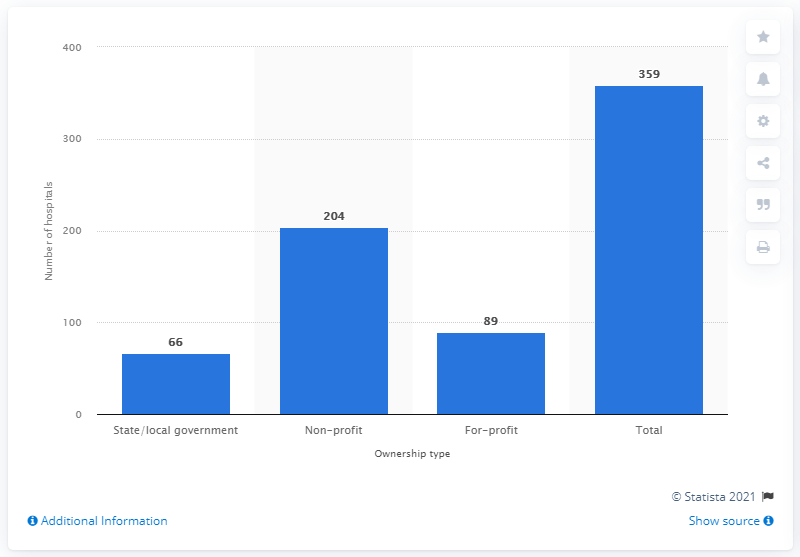List a handful of essential elements in this visual. In 2019, there were 66 hospitals in California that were owned by the state or the local government. 